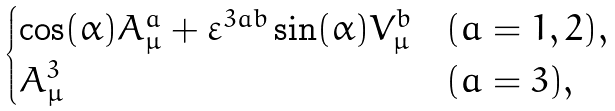<formula> <loc_0><loc_0><loc_500><loc_500>\begin{cases} \cos ( \alpha ) A _ { \mu } ^ { a } + \varepsilon ^ { 3 a b } \sin ( \alpha ) V _ { \mu } ^ { b } & \text {$(a=1,2)$} , \\ A _ { \mu } ^ { 3 } & \text {$(a=3)$} , \end{cases}</formula> 